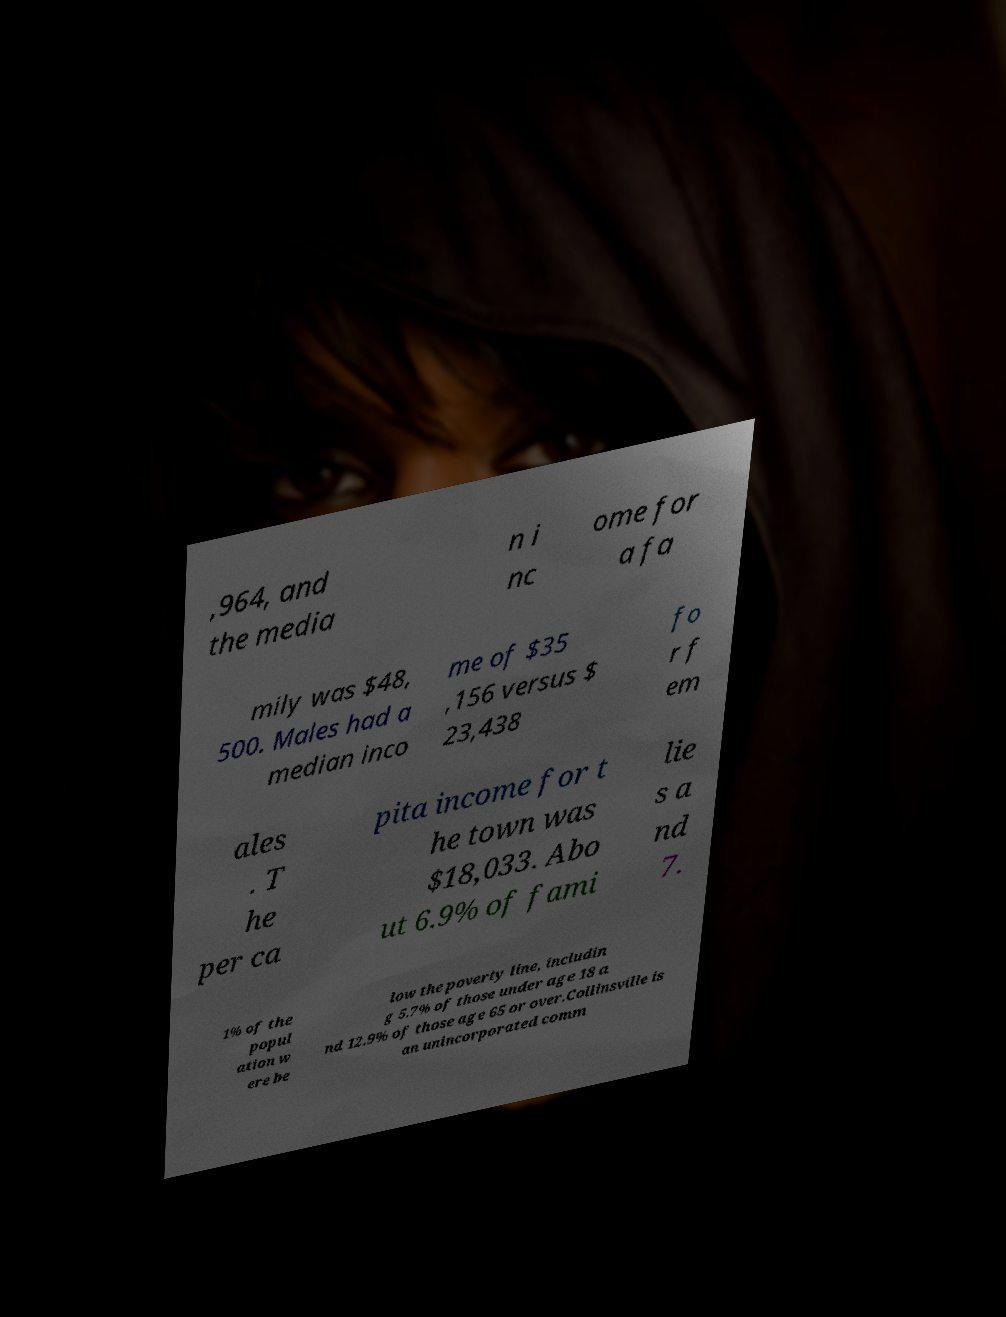Please identify and transcribe the text found in this image. ,964, and the media n i nc ome for a fa mily was $48, 500. Males had a median inco me of $35 ,156 versus $ 23,438 fo r f em ales . T he per ca pita income for t he town was $18,033. Abo ut 6.9% of fami lie s a nd 7. 1% of the popul ation w ere be low the poverty line, includin g 5.7% of those under age 18 a nd 12.9% of those age 65 or over.Collinsville is an unincorporated comm 